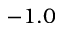Convert formula to latex. <formula><loc_0><loc_0><loc_500><loc_500>- 1 . 0</formula> 